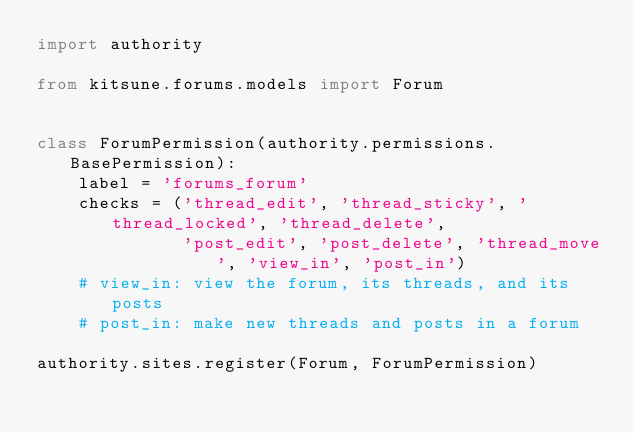Convert code to text. <code><loc_0><loc_0><loc_500><loc_500><_Python_>import authority

from kitsune.forums.models import Forum


class ForumPermission(authority.permissions.BasePermission):
    label = 'forums_forum'
    checks = ('thread_edit', 'thread_sticky', 'thread_locked', 'thread_delete',
              'post_edit', 'post_delete', 'thread_move', 'view_in', 'post_in')
    # view_in: view the forum, its threads, and its posts
    # post_in: make new threads and posts in a forum

authority.sites.register(Forum, ForumPermission)
</code> 